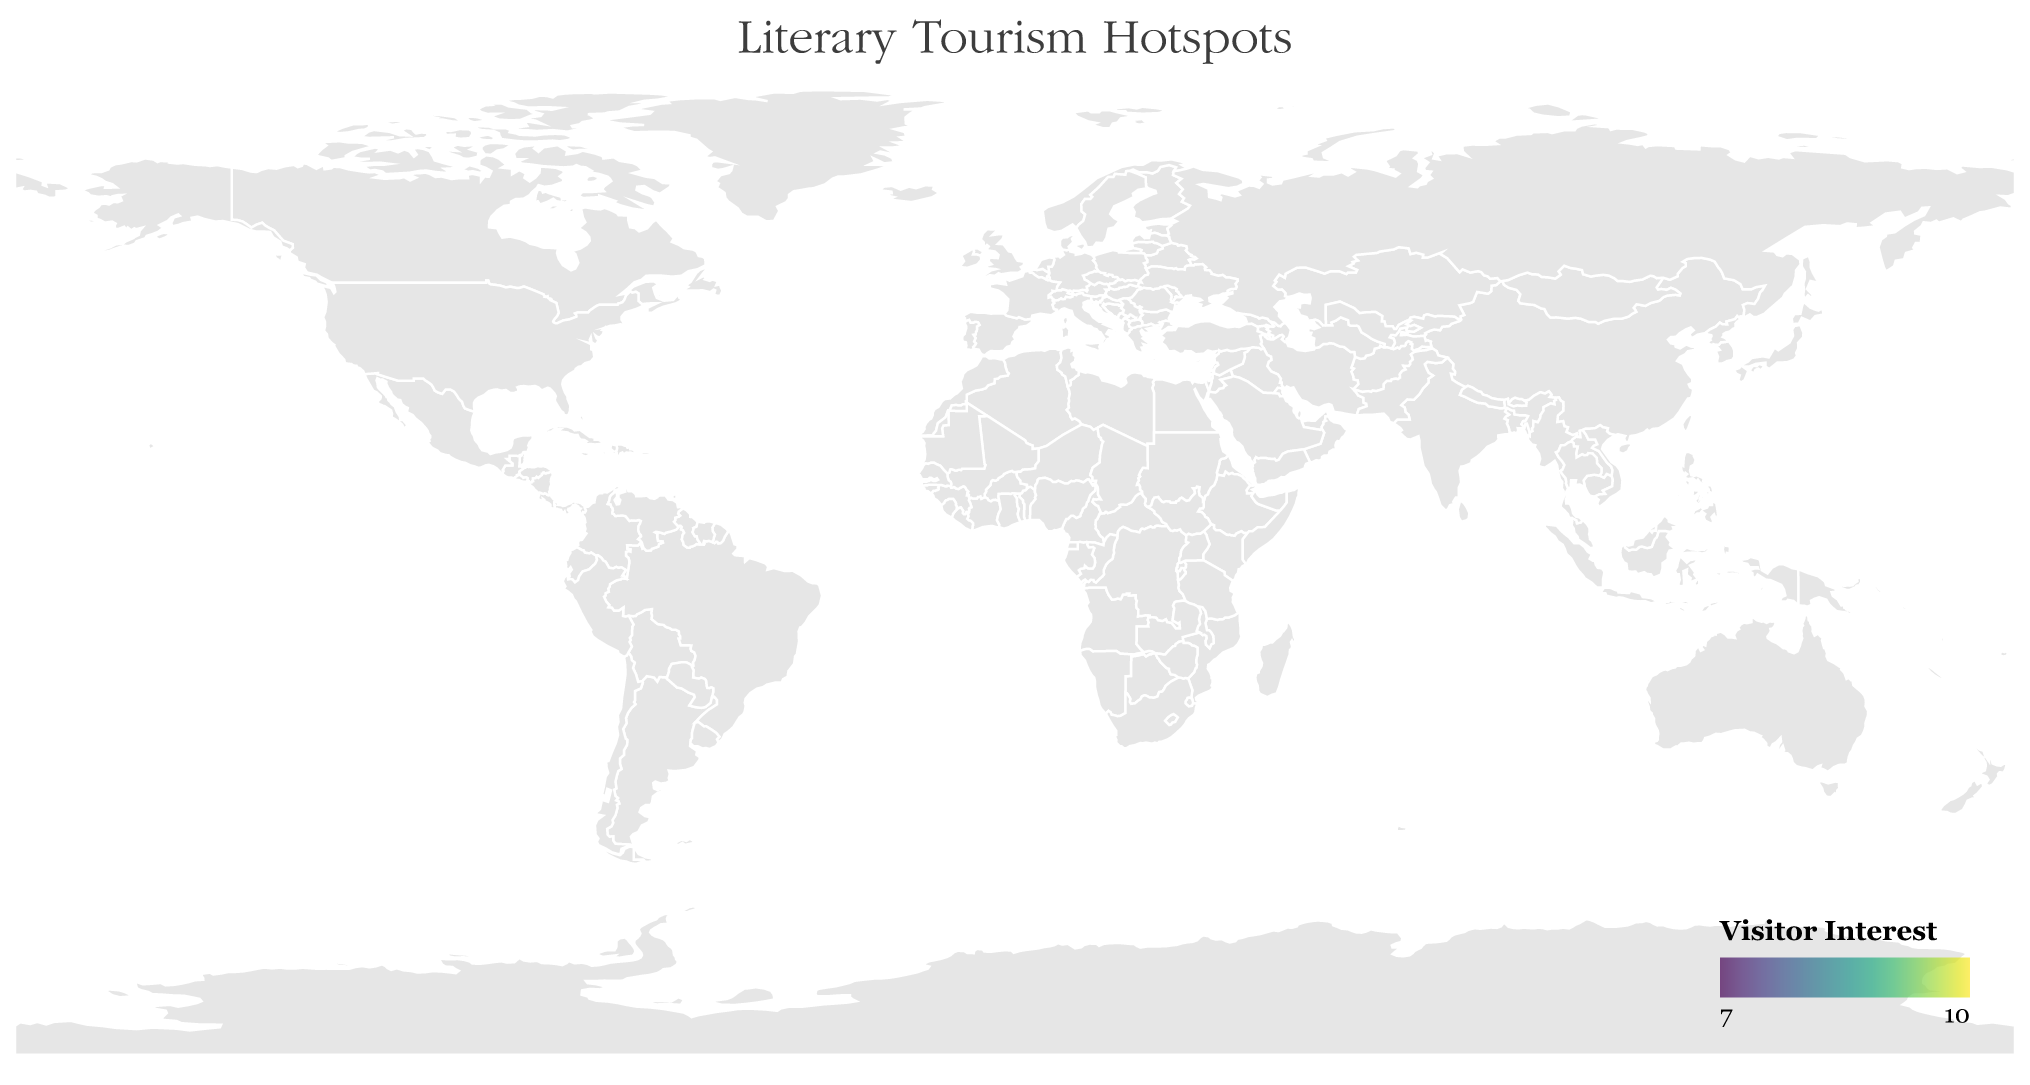What is the location on the map associated with William Shakespeare? The map title “Literary Tourism Hotspots” indicates these locations are associated with famous authors and their works. By locating William Shakespeare in the tooltip, we see he is associated with Stratford-upon-Avon.
Answer: Stratford-upon-Avon Which city has the highest Visitor Interest and who is the associated author? Referencing the Visitor Interest values, the highest stands out as 9.5. Cross-referencing this value reveals Edinburgh associated with J.K. Rowling.
Answer: Edinburgh, J.K. Rowling How does Paris compare to Monroeville in terms of Visitor Interest? Paris has a Visitor Interest of 8.9 while Monroeville has 8.1. Paris’ interest is higher.
Answer: Paris has higher Visitor Interest What is the average Visitor Interest for locations in Europe? Europe includes Stratford-upon-Avon, Dublin, Edinburgh, Paris, St. Petersburg, and Bath. Adding their interests (9.2 + 8.7 + 9.5 + 8.9 + 7.8 + 8.6) = 52.7, then divide by 6 locations: 52.7/6 = 8.78
Answer: 8.78 Which region is associated with "To Kill a Mockingbird," and what is its Visitor Interest? By observing the tooltips, Monroeville is linked to "To Kill a Mockingbird" with a Visitor Interest of 8.1.
Answer: Monroeville, 8.1 Is Ernest Hemingway’s location more popular than Leo Tolstoy’s? Ernest Hemingway’s location, Havana, has a Visitor Interest of 8.4, while Leo Tolstoy’s location, Yasnaya Polyana, has 7.2. Havana’s interest is higher.
Answer: Yes, Havana is more popular On what continent is the lowest Visitor Interest location and what is its value? Yasnaya Polyana in Europe has the lowest Visitor Interest with a score of 7.2.
Answer: Europe, 7.2 How many hotspots are located within the United States? By referencing the map and data points, we identify Concord and Monroeville within the United States.
Answer: 2 Which location associated with a female author has the highest Visitor Interest? By identifying the female authors (J.K. Rowling, Louisa May Alcott, Harper Lee, Jane Austen) and their respective locations, J.K. Rowling’s Edinburgh (9.5) holds the highest Visitor Interest.
Answer: Edinburgh 